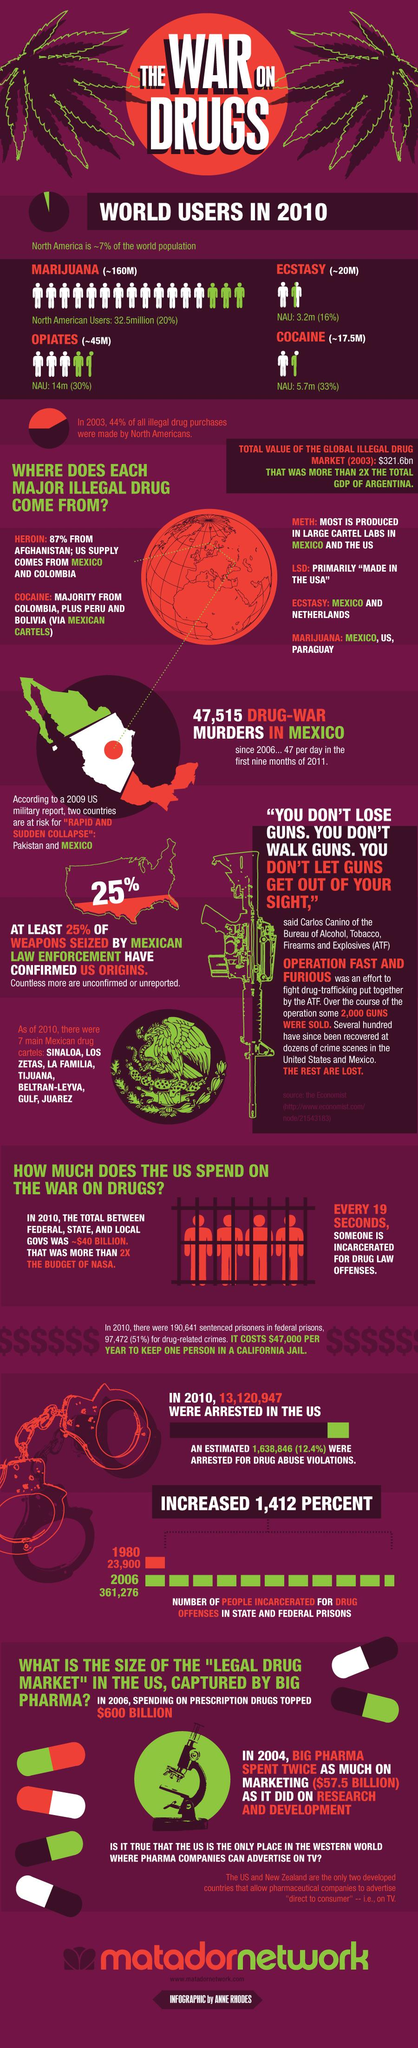Draw attention to some important aspects in this diagram. There are approximately 5.7 million North American individuals who currently use cocaine. The most commonly used illegal drug in the world is [cocaine/methamphetamine/opioids]. 